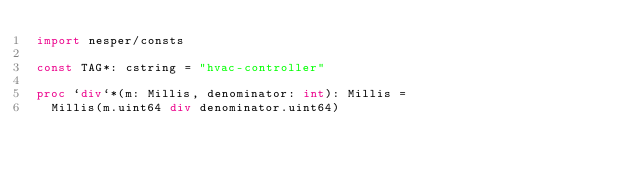<code> <loc_0><loc_0><loc_500><loc_500><_Nim_>import nesper/consts

const TAG*: cstring = "hvac-controller"

proc `div`*(m: Millis, denominator: int): Millis =
  Millis(m.uint64 div denominator.uint64)
</code> 